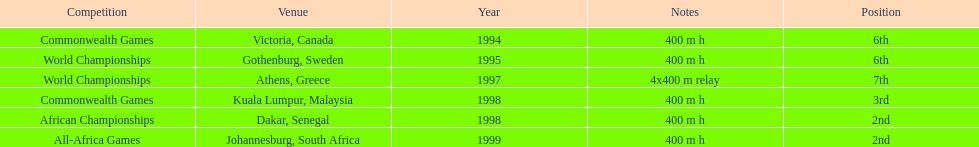Can you provide the quantity of titles that ken harden has secured? 6. 